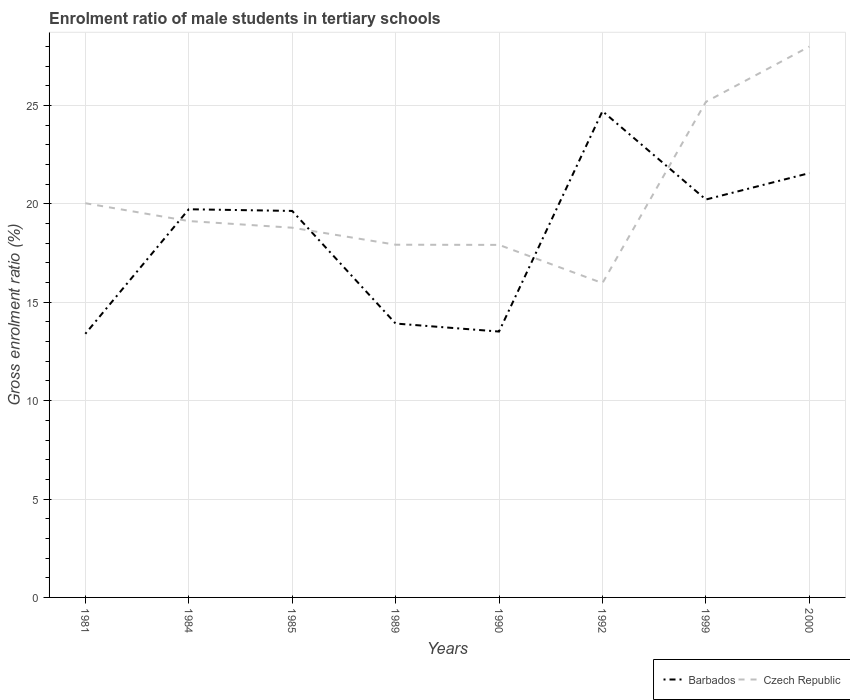Does the line corresponding to Barbados intersect with the line corresponding to Czech Republic?
Your answer should be very brief. Yes. Across all years, what is the maximum enrolment ratio of male students in tertiary schools in Barbados?
Offer a terse response. 13.4. What is the total enrolment ratio of male students in tertiary schools in Czech Republic in the graph?
Offer a terse response. 2.11. What is the difference between the highest and the second highest enrolment ratio of male students in tertiary schools in Barbados?
Keep it short and to the point. 11.31. Is the enrolment ratio of male students in tertiary schools in Czech Republic strictly greater than the enrolment ratio of male students in tertiary schools in Barbados over the years?
Offer a terse response. No. Are the values on the major ticks of Y-axis written in scientific E-notation?
Give a very brief answer. No. Does the graph contain any zero values?
Your answer should be very brief. No. Where does the legend appear in the graph?
Keep it short and to the point. Bottom right. How many legend labels are there?
Offer a very short reply. 2. How are the legend labels stacked?
Make the answer very short. Horizontal. What is the title of the graph?
Your answer should be compact. Enrolment ratio of male students in tertiary schools. What is the Gross enrolment ratio (%) of Barbados in 1981?
Give a very brief answer. 13.4. What is the Gross enrolment ratio (%) of Czech Republic in 1981?
Make the answer very short. 20.03. What is the Gross enrolment ratio (%) in Barbados in 1984?
Your response must be concise. 19.73. What is the Gross enrolment ratio (%) in Czech Republic in 1984?
Offer a very short reply. 19.13. What is the Gross enrolment ratio (%) in Barbados in 1985?
Give a very brief answer. 19.64. What is the Gross enrolment ratio (%) of Czech Republic in 1985?
Offer a terse response. 18.79. What is the Gross enrolment ratio (%) in Barbados in 1989?
Your answer should be compact. 13.92. What is the Gross enrolment ratio (%) of Czech Republic in 1989?
Make the answer very short. 17.93. What is the Gross enrolment ratio (%) of Barbados in 1990?
Offer a very short reply. 13.51. What is the Gross enrolment ratio (%) of Czech Republic in 1990?
Give a very brief answer. 17.92. What is the Gross enrolment ratio (%) of Barbados in 1992?
Keep it short and to the point. 24.71. What is the Gross enrolment ratio (%) of Czech Republic in 1992?
Your answer should be compact. 15.98. What is the Gross enrolment ratio (%) in Barbados in 1999?
Keep it short and to the point. 20.22. What is the Gross enrolment ratio (%) of Czech Republic in 1999?
Offer a very short reply. 25.19. What is the Gross enrolment ratio (%) of Barbados in 2000?
Offer a terse response. 21.56. What is the Gross enrolment ratio (%) in Czech Republic in 2000?
Ensure brevity in your answer.  27.99. Across all years, what is the maximum Gross enrolment ratio (%) of Barbados?
Keep it short and to the point. 24.71. Across all years, what is the maximum Gross enrolment ratio (%) in Czech Republic?
Offer a very short reply. 27.99. Across all years, what is the minimum Gross enrolment ratio (%) of Barbados?
Make the answer very short. 13.4. Across all years, what is the minimum Gross enrolment ratio (%) in Czech Republic?
Your answer should be compact. 15.98. What is the total Gross enrolment ratio (%) of Barbados in the graph?
Make the answer very short. 146.7. What is the total Gross enrolment ratio (%) in Czech Republic in the graph?
Provide a short and direct response. 162.95. What is the difference between the Gross enrolment ratio (%) of Barbados in 1981 and that in 1984?
Your response must be concise. -6.33. What is the difference between the Gross enrolment ratio (%) in Czech Republic in 1981 and that in 1984?
Provide a short and direct response. 0.91. What is the difference between the Gross enrolment ratio (%) in Barbados in 1981 and that in 1985?
Ensure brevity in your answer.  -6.24. What is the difference between the Gross enrolment ratio (%) in Czech Republic in 1981 and that in 1985?
Give a very brief answer. 1.24. What is the difference between the Gross enrolment ratio (%) of Barbados in 1981 and that in 1989?
Your answer should be compact. -0.52. What is the difference between the Gross enrolment ratio (%) of Czech Republic in 1981 and that in 1989?
Provide a short and direct response. 2.11. What is the difference between the Gross enrolment ratio (%) in Barbados in 1981 and that in 1990?
Make the answer very short. -0.11. What is the difference between the Gross enrolment ratio (%) in Czech Republic in 1981 and that in 1990?
Keep it short and to the point. 2.12. What is the difference between the Gross enrolment ratio (%) of Barbados in 1981 and that in 1992?
Provide a succinct answer. -11.31. What is the difference between the Gross enrolment ratio (%) of Czech Republic in 1981 and that in 1992?
Offer a terse response. 4.06. What is the difference between the Gross enrolment ratio (%) in Barbados in 1981 and that in 1999?
Provide a succinct answer. -6.82. What is the difference between the Gross enrolment ratio (%) of Czech Republic in 1981 and that in 1999?
Provide a short and direct response. -5.15. What is the difference between the Gross enrolment ratio (%) of Barbados in 1981 and that in 2000?
Ensure brevity in your answer.  -8.17. What is the difference between the Gross enrolment ratio (%) of Czech Republic in 1981 and that in 2000?
Offer a terse response. -7.96. What is the difference between the Gross enrolment ratio (%) in Barbados in 1984 and that in 1985?
Offer a very short reply. 0.08. What is the difference between the Gross enrolment ratio (%) of Czech Republic in 1984 and that in 1985?
Provide a succinct answer. 0.34. What is the difference between the Gross enrolment ratio (%) of Barbados in 1984 and that in 1989?
Offer a terse response. 5.81. What is the difference between the Gross enrolment ratio (%) of Czech Republic in 1984 and that in 1989?
Your response must be concise. 1.2. What is the difference between the Gross enrolment ratio (%) of Barbados in 1984 and that in 1990?
Provide a succinct answer. 6.21. What is the difference between the Gross enrolment ratio (%) in Czech Republic in 1984 and that in 1990?
Your answer should be compact. 1.21. What is the difference between the Gross enrolment ratio (%) in Barbados in 1984 and that in 1992?
Your answer should be compact. -4.98. What is the difference between the Gross enrolment ratio (%) in Czech Republic in 1984 and that in 1992?
Keep it short and to the point. 3.15. What is the difference between the Gross enrolment ratio (%) of Barbados in 1984 and that in 1999?
Provide a succinct answer. -0.49. What is the difference between the Gross enrolment ratio (%) in Czech Republic in 1984 and that in 1999?
Your answer should be compact. -6.06. What is the difference between the Gross enrolment ratio (%) in Barbados in 1984 and that in 2000?
Keep it short and to the point. -1.84. What is the difference between the Gross enrolment ratio (%) in Czech Republic in 1984 and that in 2000?
Provide a short and direct response. -8.87. What is the difference between the Gross enrolment ratio (%) of Barbados in 1985 and that in 1989?
Keep it short and to the point. 5.72. What is the difference between the Gross enrolment ratio (%) of Czech Republic in 1985 and that in 1989?
Offer a very short reply. 0.87. What is the difference between the Gross enrolment ratio (%) of Barbados in 1985 and that in 1990?
Your answer should be compact. 6.13. What is the difference between the Gross enrolment ratio (%) in Czech Republic in 1985 and that in 1990?
Ensure brevity in your answer.  0.87. What is the difference between the Gross enrolment ratio (%) in Barbados in 1985 and that in 1992?
Offer a very short reply. -5.07. What is the difference between the Gross enrolment ratio (%) in Czech Republic in 1985 and that in 1992?
Your answer should be very brief. 2.81. What is the difference between the Gross enrolment ratio (%) in Barbados in 1985 and that in 1999?
Provide a short and direct response. -0.58. What is the difference between the Gross enrolment ratio (%) in Czech Republic in 1985 and that in 1999?
Offer a very short reply. -6.4. What is the difference between the Gross enrolment ratio (%) of Barbados in 1985 and that in 2000?
Your answer should be very brief. -1.92. What is the difference between the Gross enrolment ratio (%) of Czech Republic in 1985 and that in 2000?
Offer a very short reply. -9.2. What is the difference between the Gross enrolment ratio (%) in Barbados in 1989 and that in 1990?
Provide a short and direct response. 0.41. What is the difference between the Gross enrolment ratio (%) of Czech Republic in 1989 and that in 1990?
Ensure brevity in your answer.  0.01. What is the difference between the Gross enrolment ratio (%) in Barbados in 1989 and that in 1992?
Offer a terse response. -10.79. What is the difference between the Gross enrolment ratio (%) in Czech Republic in 1989 and that in 1992?
Make the answer very short. 1.95. What is the difference between the Gross enrolment ratio (%) of Barbados in 1989 and that in 1999?
Ensure brevity in your answer.  -6.3. What is the difference between the Gross enrolment ratio (%) in Czech Republic in 1989 and that in 1999?
Keep it short and to the point. -7.26. What is the difference between the Gross enrolment ratio (%) of Barbados in 1989 and that in 2000?
Keep it short and to the point. -7.64. What is the difference between the Gross enrolment ratio (%) of Czech Republic in 1989 and that in 2000?
Give a very brief answer. -10.07. What is the difference between the Gross enrolment ratio (%) in Barbados in 1990 and that in 1992?
Make the answer very short. -11.2. What is the difference between the Gross enrolment ratio (%) in Czech Republic in 1990 and that in 1992?
Offer a terse response. 1.94. What is the difference between the Gross enrolment ratio (%) in Barbados in 1990 and that in 1999?
Your response must be concise. -6.71. What is the difference between the Gross enrolment ratio (%) in Czech Republic in 1990 and that in 1999?
Provide a short and direct response. -7.27. What is the difference between the Gross enrolment ratio (%) of Barbados in 1990 and that in 2000?
Your answer should be compact. -8.05. What is the difference between the Gross enrolment ratio (%) in Czech Republic in 1990 and that in 2000?
Offer a terse response. -10.08. What is the difference between the Gross enrolment ratio (%) of Barbados in 1992 and that in 1999?
Ensure brevity in your answer.  4.49. What is the difference between the Gross enrolment ratio (%) in Czech Republic in 1992 and that in 1999?
Keep it short and to the point. -9.21. What is the difference between the Gross enrolment ratio (%) of Barbados in 1992 and that in 2000?
Offer a very short reply. 3.15. What is the difference between the Gross enrolment ratio (%) in Czech Republic in 1992 and that in 2000?
Keep it short and to the point. -12.02. What is the difference between the Gross enrolment ratio (%) of Barbados in 1999 and that in 2000?
Provide a succinct answer. -1.34. What is the difference between the Gross enrolment ratio (%) in Czech Republic in 1999 and that in 2000?
Make the answer very short. -2.81. What is the difference between the Gross enrolment ratio (%) in Barbados in 1981 and the Gross enrolment ratio (%) in Czech Republic in 1984?
Offer a terse response. -5.73. What is the difference between the Gross enrolment ratio (%) of Barbados in 1981 and the Gross enrolment ratio (%) of Czech Republic in 1985?
Ensure brevity in your answer.  -5.39. What is the difference between the Gross enrolment ratio (%) in Barbados in 1981 and the Gross enrolment ratio (%) in Czech Republic in 1989?
Provide a succinct answer. -4.53. What is the difference between the Gross enrolment ratio (%) in Barbados in 1981 and the Gross enrolment ratio (%) in Czech Republic in 1990?
Provide a short and direct response. -4.52. What is the difference between the Gross enrolment ratio (%) of Barbados in 1981 and the Gross enrolment ratio (%) of Czech Republic in 1992?
Provide a short and direct response. -2.58. What is the difference between the Gross enrolment ratio (%) in Barbados in 1981 and the Gross enrolment ratio (%) in Czech Republic in 1999?
Provide a short and direct response. -11.79. What is the difference between the Gross enrolment ratio (%) in Barbados in 1981 and the Gross enrolment ratio (%) in Czech Republic in 2000?
Your answer should be very brief. -14.6. What is the difference between the Gross enrolment ratio (%) of Barbados in 1984 and the Gross enrolment ratio (%) of Czech Republic in 1985?
Give a very brief answer. 0.94. What is the difference between the Gross enrolment ratio (%) of Barbados in 1984 and the Gross enrolment ratio (%) of Czech Republic in 1989?
Offer a very short reply. 1.8. What is the difference between the Gross enrolment ratio (%) of Barbados in 1984 and the Gross enrolment ratio (%) of Czech Republic in 1990?
Your response must be concise. 1.81. What is the difference between the Gross enrolment ratio (%) of Barbados in 1984 and the Gross enrolment ratio (%) of Czech Republic in 1992?
Offer a terse response. 3.75. What is the difference between the Gross enrolment ratio (%) in Barbados in 1984 and the Gross enrolment ratio (%) in Czech Republic in 1999?
Provide a short and direct response. -5.46. What is the difference between the Gross enrolment ratio (%) in Barbados in 1984 and the Gross enrolment ratio (%) in Czech Republic in 2000?
Provide a short and direct response. -8.27. What is the difference between the Gross enrolment ratio (%) of Barbados in 1985 and the Gross enrolment ratio (%) of Czech Republic in 1989?
Your answer should be very brief. 1.72. What is the difference between the Gross enrolment ratio (%) in Barbados in 1985 and the Gross enrolment ratio (%) in Czech Republic in 1990?
Your answer should be very brief. 1.73. What is the difference between the Gross enrolment ratio (%) in Barbados in 1985 and the Gross enrolment ratio (%) in Czech Republic in 1992?
Ensure brevity in your answer.  3.67. What is the difference between the Gross enrolment ratio (%) in Barbados in 1985 and the Gross enrolment ratio (%) in Czech Republic in 1999?
Make the answer very short. -5.54. What is the difference between the Gross enrolment ratio (%) of Barbados in 1985 and the Gross enrolment ratio (%) of Czech Republic in 2000?
Ensure brevity in your answer.  -8.35. What is the difference between the Gross enrolment ratio (%) of Barbados in 1989 and the Gross enrolment ratio (%) of Czech Republic in 1990?
Offer a very short reply. -4. What is the difference between the Gross enrolment ratio (%) of Barbados in 1989 and the Gross enrolment ratio (%) of Czech Republic in 1992?
Provide a succinct answer. -2.06. What is the difference between the Gross enrolment ratio (%) in Barbados in 1989 and the Gross enrolment ratio (%) in Czech Republic in 1999?
Make the answer very short. -11.27. What is the difference between the Gross enrolment ratio (%) in Barbados in 1989 and the Gross enrolment ratio (%) in Czech Republic in 2000?
Offer a very short reply. -14.07. What is the difference between the Gross enrolment ratio (%) in Barbados in 1990 and the Gross enrolment ratio (%) in Czech Republic in 1992?
Ensure brevity in your answer.  -2.46. What is the difference between the Gross enrolment ratio (%) of Barbados in 1990 and the Gross enrolment ratio (%) of Czech Republic in 1999?
Provide a succinct answer. -11.67. What is the difference between the Gross enrolment ratio (%) in Barbados in 1990 and the Gross enrolment ratio (%) in Czech Republic in 2000?
Make the answer very short. -14.48. What is the difference between the Gross enrolment ratio (%) in Barbados in 1992 and the Gross enrolment ratio (%) in Czech Republic in 1999?
Provide a short and direct response. -0.47. What is the difference between the Gross enrolment ratio (%) of Barbados in 1992 and the Gross enrolment ratio (%) of Czech Republic in 2000?
Provide a short and direct response. -3.28. What is the difference between the Gross enrolment ratio (%) of Barbados in 1999 and the Gross enrolment ratio (%) of Czech Republic in 2000?
Your response must be concise. -7.77. What is the average Gross enrolment ratio (%) of Barbados per year?
Make the answer very short. 18.34. What is the average Gross enrolment ratio (%) of Czech Republic per year?
Ensure brevity in your answer.  20.37. In the year 1981, what is the difference between the Gross enrolment ratio (%) in Barbados and Gross enrolment ratio (%) in Czech Republic?
Give a very brief answer. -6.64. In the year 1984, what is the difference between the Gross enrolment ratio (%) of Barbados and Gross enrolment ratio (%) of Czech Republic?
Your response must be concise. 0.6. In the year 1985, what is the difference between the Gross enrolment ratio (%) of Barbados and Gross enrolment ratio (%) of Czech Republic?
Offer a terse response. 0.85. In the year 1989, what is the difference between the Gross enrolment ratio (%) of Barbados and Gross enrolment ratio (%) of Czech Republic?
Ensure brevity in your answer.  -4.01. In the year 1990, what is the difference between the Gross enrolment ratio (%) of Barbados and Gross enrolment ratio (%) of Czech Republic?
Offer a very short reply. -4.4. In the year 1992, what is the difference between the Gross enrolment ratio (%) in Barbados and Gross enrolment ratio (%) in Czech Republic?
Your response must be concise. 8.74. In the year 1999, what is the difference between the Gross enrolment ratio (%) of Barbados and Gross enrolment ratio (%) of Czech Republic?
Ensure brevity in your answer.  -4.96. In the year 2000, what is the difference between the Gross enrolment ratio (%) of Barbados and Gross enrolment ratio (%) of Czech Republic?
Keep it short and to the point. -6.43. What is the ratio of the Gross enrolment ratio (%) of Barbados in 1981 to that in 1984?
Give a very brief answer. 0.68. What is the ratio of the Gross enrolment ratio (%) of Czech Republic in 1981 to that in 1984?
Provide a short and direct response. 1.05. What is the ratio of the Gross enrolment ratio (%) of Barbados in 1981 to that in 1985?
Provide a succinct answer. 0.68. What is the ratio of the Gross enrolment ratio (%) in Czech Republic in 1981 to that in 1985?
Provide a short and direct response. 1.07. What is the ratio of the Gross enrolment ratio (%) of Barbados in 1981 to that in 1989?
Provide a succinct answer. 0.96. What is the ratio of the Gross enrolment ratio (%) in Czech Republic in 1981 to that in 1989?
Your answer should be compact. 1.12. What is the ratio of the Gross enrolment ratio (%) of Barbados in 1981 to that in 1990?
Your answer should be very brief. 0.99. What is the ratio of the Gross enrolment ratio (%) of Czech Republic in 1981 to that in 1990?
Ensure brevity in your answer.  1.12. What is the ratio of the Gross enrolment ratio (%) in Barbados in 1981 to that in 1992?
Ensure brevity in your answer.  0.54. What is the ratio of the Gross enrolment ratio (%) in Czech Republic in 1981 to that in 1992?
Provide a succinct answer. 1.25. What is the ratio of the Gross enrolment ratio (%) in Barbados in 1981 to that in 1999?
Offer a very short reply. 0.66. What is the ratio of the Gross enrolment ratio (%) in Czech Republic in 1981 to that in 1999?
Keep it short and to the point. 0.8. What is the ratio of the Gross enrolment ratio (%) in Barbados in 1981 to that in 2000?
Keep it short and to the point. 0.62. What is the ratio of the Gross enrolment ratio (%) of Czech Republic in 1981 to that in 2000?
Your answer should be very brief. 0.72. What is the ratio of the Gross enrolment ratio (%) of Barbados in 1984 to that in 1985?
Ensure brevity in your answer.  1. What is the ratio of the Gross enrolment ratio (%) in Barbados in 1984 to that in 1989?
Ensure brevity in your answer.  1.42. What is the ratio of the Gross enrolment ratio (%) of Czech Republic in 1984 to that in 1989?
Make the answer very short. 1.07. What is the ratio of the Gross enrolment ratio (%) of Barbados in 1984 to that in 1990?
Provide a succinct answer. 1.46. What is the ratio of the Gross enrolment ratio (%) of Czech Republic in 1984 to that in 1990?
Offer a terse response. 1.07. What is the ratio of the Gross enrolment ratio (%) in Barbados in 1984 to that in 1992?
Your response must be concise. 0.8. What is the ratio of the Gross enrolment ratio (%) in Czech Republic in 1984 to that in 1992?
Give a very brief answer. 1.2. What is the ratio of the Gross enrolment ratio (%) in Barbados in 1984 to that in 1999?
Give a very brief answer. 0.98. What is the ratio of the Gross enrolment ratio (%) of Czech Republic in 1984 to that in 1999?
Your answer should be compact. 0.76. What is the ratio of the Gross enrolment ratio (%) in Barbados in 1984 to that in 2000?
Your answer should be compact. 0.91. What is the ratio of the Gross enrolment ratio (%) of Czech Republic in 1984 to that in 2000?
Your response must be concise. 0.68. What is the ratio of the Gross enrolment ratio (%) of Barbados in 1985 to that in 1989?
Ensure brevity in your answer.  1.41. What is the ratio of the Gross enrolment ratio (%) in Czech Republic in 1985 to that in 1989?
Provide a short and direct response. 1.05. What is the ratio of the Gross enrolment ratio (%) of Barbados in 1985 to that in 1990?
Keep it short and to the point. 1.45. What is the ratio of the Gross enrolment ratio (%) in Czech Republic in 1985 to that in 1990?
Give a very brief answer. 1.05. What is the ratio of the Gross enrolment ratio (%) of Barbados in 1985 to that in 1992?
Give a very brief answer. 0.79. What is the ratio of the Gross enrolment ratio (%) in Czech Republic in 1985 to that in 1992?
Provide a succinct answer. 1.18. What is the ratio of the Gross enrolment ratio (%) in Barbados in 1985 to that in 1999?
Ensure brevity in your answer.  0.97. What is the ratio of the Gross enrolment ratio (%) in Czech Republic in 1985 to that in 1999?
Your response must be concise. 0.75. What is the ratio of the Gross enrolment ratio (%) in Barbados in 1985 to that in 2000?
Offer a very short reply. 0.91. What is the ratio of the Gross enrolment ratio (%) in Czech Republic in 1985 to that in 2000?
Make the answer very short. 0.67. What is the ratio of the Gross enrolment ratio (%) of Barbados in 1989 to that in 1990?
Provide a succinct answer. 1.03. What is the ratio of the Gross enrolment ratio (%) of Barbados in 1989 to that in 1992?
Make the answer very short. 0.56. What is the ratio of the Gross enrolment ratio (%) in Czech Republic in 1989 to that in 1992?
Provide a succinct answer. 1.12. What is the ratio of the Gross enrolment ratio (%) in Barbados in 1989 to that in 1999?
Ensure brevity in your answer.  0.69. What is the ratio of the Gross enrolment ratio (%) in Czech Republic in 1989 to that in 1999?
Offer a very short reply. 0.71. What is the ratio of the Gross enrolment ratio (%) of Barbados in 1989 to that in 2000?
Provide a succinct answer. 0.65. What is the ratio of the Gross enrolment ratio (%) of Czech Republic in 1989 to that in 2000?
Offer a very short reply. 0.64. What is the ratio of the Gross enrolment ratio (%) of Barbados in 1990 to that in 1992?
Offer a terse response. 0.55. What is the ratio of the Gross enrolment ratio (%) in Czech Republic in 1990 to that in 1992?
Your response must be concise. 1.12. What is the ratio of the Gross enrolment ratio (%) of Barbados in 1990 to that in 1999?
Ensure brevity in your answer.  0.67. What is the ratio of the Gross enrolment ratio (%) of Czech Republic in 1990 to that in 1999?
Offer a very short reply. 0.71. What is the ratio of the Gross enrolment ratio (%) in Barbados in 1990 to that in 2000?
Ensure brevity in your answer.  0.63. What is the ratio of the Gross enrolment ratio (%) of Czech Republic in 1990 to that in 2000?
Keep it short and to the point. 0.64. What is the ratio of the Gross enrolment ratio (%) in Barbados in 1992 to that in 1999?
Offer a terse response. 1.22. What is the ratio of the Gross enrolment ratio (%) in Czech Republic in 1992 to that in 1999?
Provide a short and direct response. 0.63. What is the ratio of the Gross enrolment ratio (%) of Barbados in 1992 to that in 2000?
Ensure brevity in your answer.  1.15. What is the ratio of the Gross enrolment ratio (%) in Czech Republic in 1992 to that in 2000?
Offer a very short reply. 0.57. What is the ratio of the Gross enrolment ratio (%) in Barbados in 1999 to that in 2000?
Keep it short and to the point. 0.94. What is the ratio of the Gross enrolment ratio (%) of Czech Republic in 1999 to that in 2000?
Ensure brevity in your answer.  0.9. What is the difference between the highest and the second highest Gross enrolment ratio (%) of Barbados?
Your answer should be compact. 3.15. What is the difference between the highest and the second highest Gross enrolment ratio (%) of Czech Republic?
Provide a succinct answer. 2.81. What is the difference between the highest and the lowest Gross enrolment ratio (%) in Barbados?
Give a very brief answer. 11.31. What is the difference between the highest and the lowest Gross enrolment ratio (%) of Czech Republic?
Your response must be concise. 12.02. 